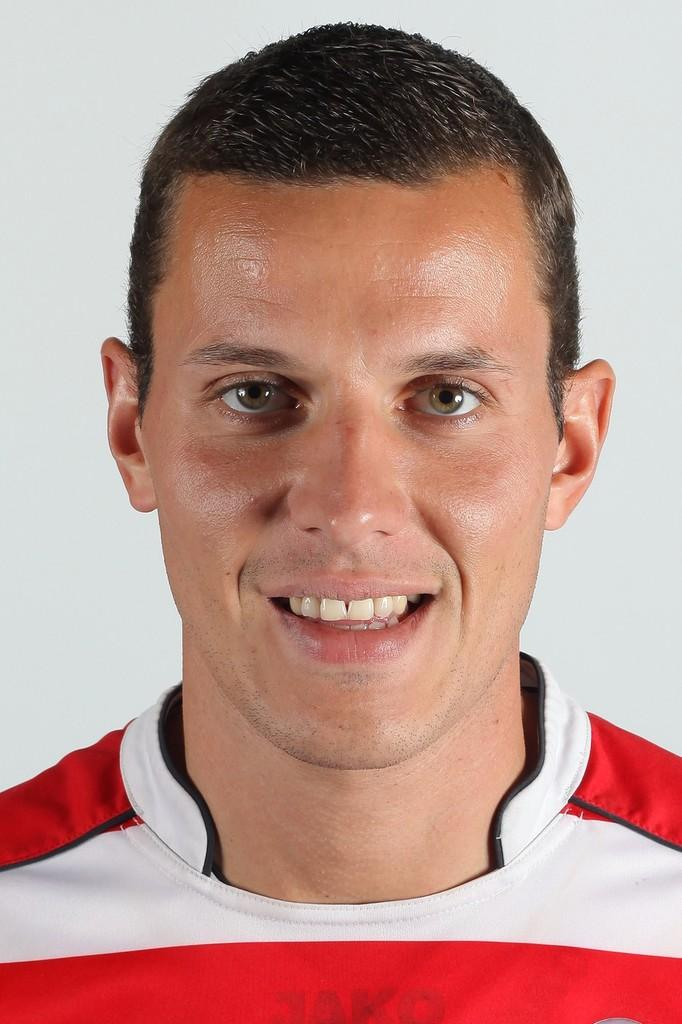Who is present in the image? There is a man in the image. What is the man's facial expression? The man is smiling. What color is the background of the image? The background of the image is white. What type of substance is the man offering to the women in the image? There are no women present in the image, and the man is not offering any substance. 